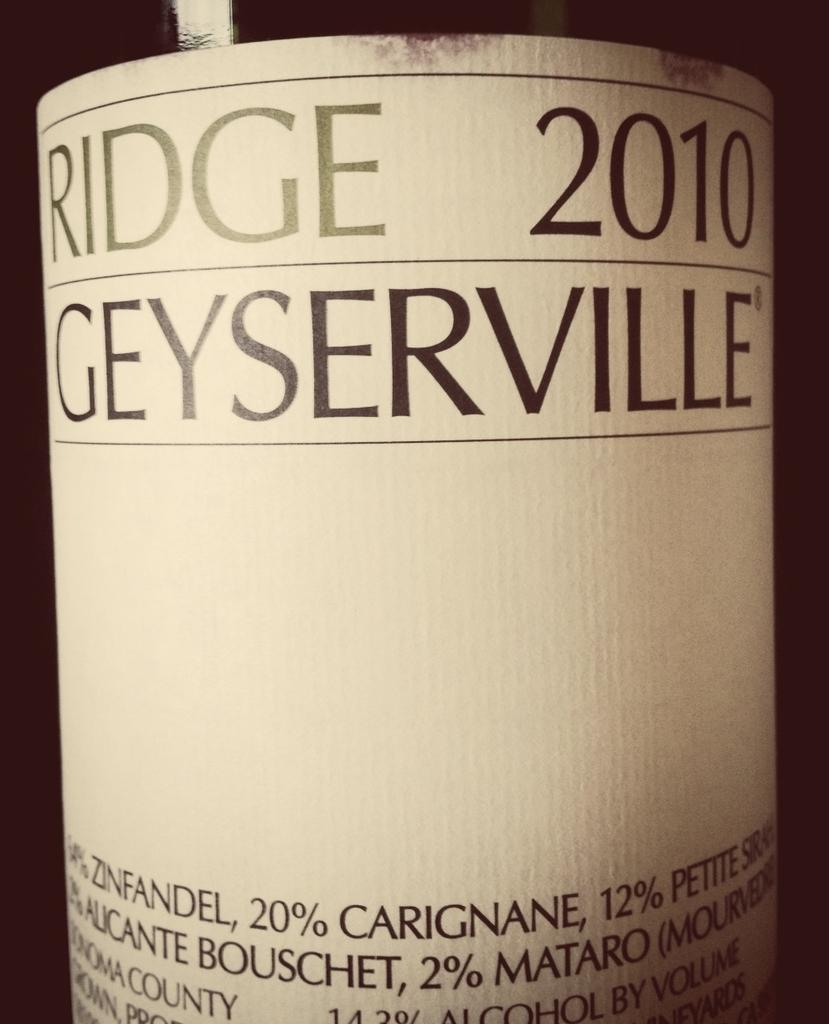<image>
Write a terse but informative summary of the picture. the year 2010 that is on a bottle 